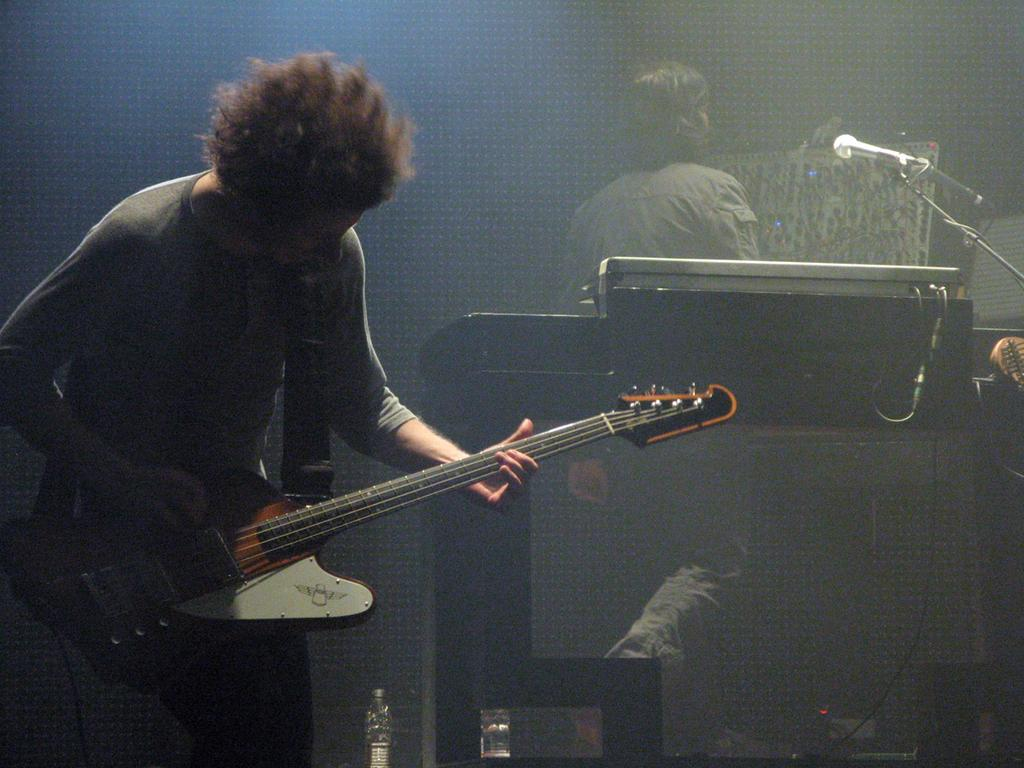What is the person in the image doing? The person is holding a guitar and playing it. What object is the person playing? There is a musical instrument (guitar) in the image. What is the person doing besides playing the guitar? The person is walking. What is used for amplifying the person's voice in the image? There is a microphone (mic) and a mic stand in the image. What can be seen on the floor in the image? There are bottles on the floor. What type of rock can be seen in the background of the image? There is no rock visible in the image; it is an indoor setting with a person playing a guitar, walking, and using a microphone and mic stand. 